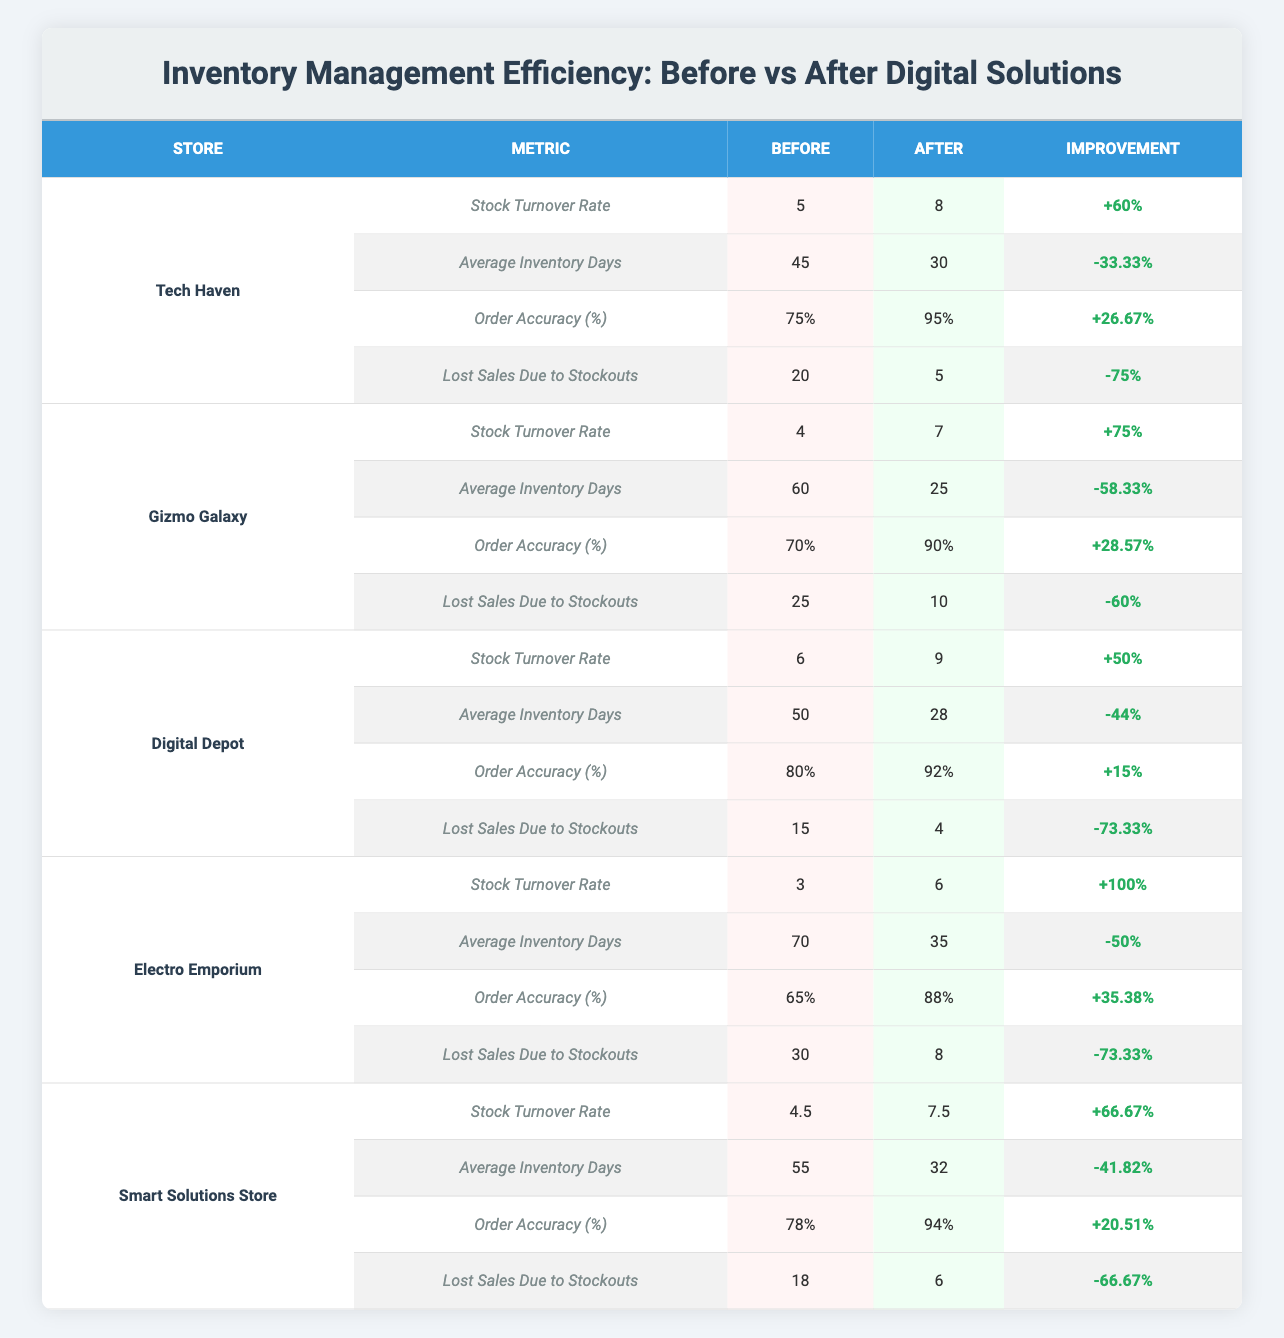What was the stock turnover rate for Digital Depot before the implementation? The table shows that the stock turnover rate for Digital Depot before implementation was 6.
Answer: 6 Which store experienced the highest improvement in stock turnover rate? Electro Emporium had a stock turnover rate increase from 3 to 6, resulting in a 100% improvement, which is the highest among all stores.
Answer: Electro Emporium What percentage did lost sales due to stockouts decrease for Tech Haven? The lost sales due to stockouts for Tech Haven decreased from 20 to 5. To find the percentage decrease: (20 - 5) / 20 * 100 = 75%.
Answer: 75% What is the average order accuracy percentage after implementing digital solutions across all stores? The order accuracy percentages after implementation are 95%, 90%, 92%, 88%, and 94%. The average is (95 + 90 + 92 + 88 + 94) / 5 = 91.80%.
Answer: 91.80% Which store shows a reduction in average inventory days greater than 50%? The average inventory days for Gizmo Galaxy decreased from 60 to 25 days, which is a reduction of 58.33%. This is greater than 50%.
Answer: Gizmo Galaxy Did Smart Solutions Store improve its order accuracy percentage after the implementation? Yes, the order accuracy percentage increased from 78% before implementation to 94% after.
Answer: Yes Which store had the most significant reduction in lost sales due to stockouts post-implementation? Electro Emporium saw lost sales due to stockouts decrease from 30 to 8. The decrease is 73.33%, which is significant.
Answer: Electro Emporium Compute the total percentage improvement in order accuracy for all stores combined. The order accuracy improvements are 26.67%, 28.57%, 15%, 35.38%, and 20.51%. Total improvement is 26.67 + 28.57 + 15 + 35.38 + 20.51 = 126.13%. Average improvement is 126.13 / 5 = 25.23%.
Answer: 25.23% Is the improvement in stock turnover rate at Digital Depot greater than that at Tech Haven? Digital Depot improved its stock turnover rate by 50% (from 6 to 9), while Tech Haven improved by 60% (from 5 to 8). Thus, Tech Haven's improvement is greater.
Answer: No What was the average number of inventory days across all stores before implementation? The average before implementation is (45 + 60 + 50 + 70 + 55) / 5 = 58 days.
Answer: 58 Which store had an increase in average inventory days after implementing digital solutions? Electro Emporium's average inventory days decreased from 70 to 35. Thus, no store had an increase in average inventory days; all showed a decrease.
Answer: No store had an increase 